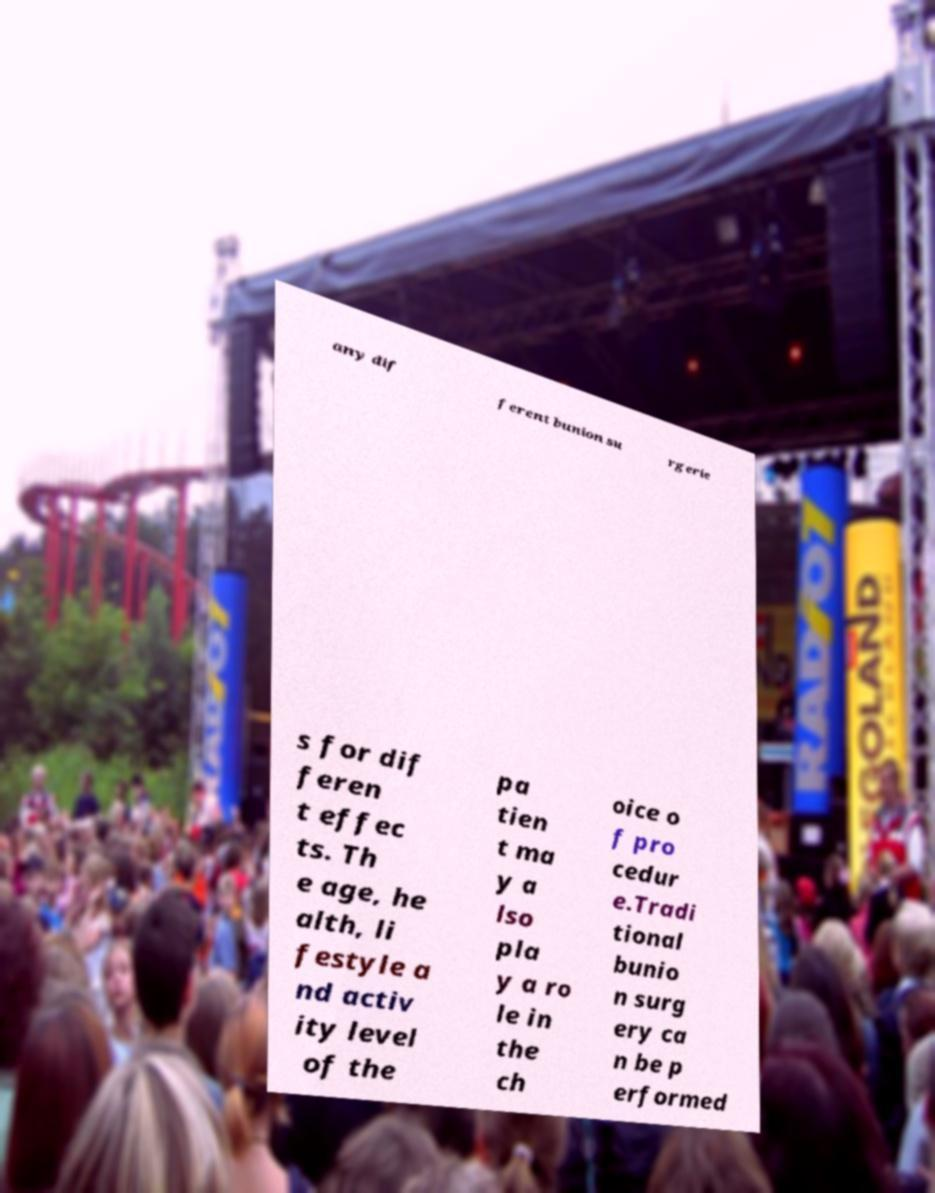What messages or text are displayed in this image? I need them in a readable, typed format. any dif ferent bunion su rgerie s for dif feren t effec ts. Th e age, he alth, li festyle a nd activ ity level of the pa tien t ma y a lso pla y a ro le in the ch oice o f pro cedur e.Tradi tional bunio n surg ery ca n be p erformed 